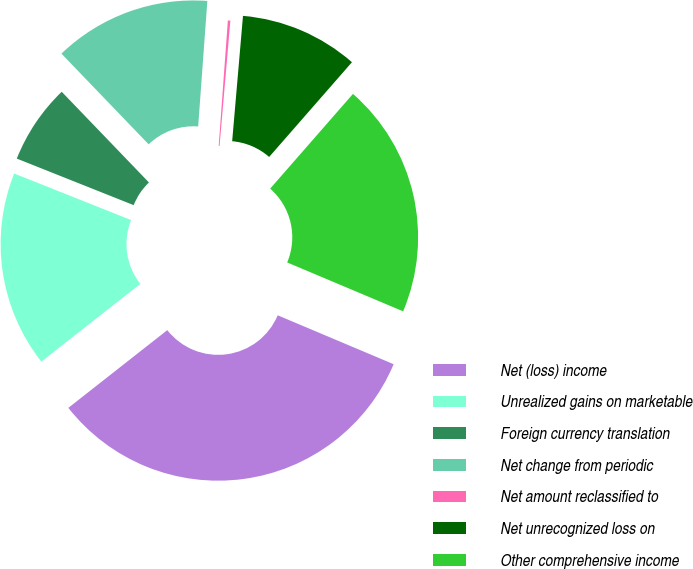Convert chart to OTSL. <chart><loc_0><loc_0><loc_500><loc_500><pie_chart><fcel>Net (loss) income<fcel>Unrealized gains on marketable<fcel>Foreign currency translation<fcel>Net change from periodic<fcel>Net amount reclassified to<fcel>Net unrecognized loss on<fcel>Other comprehensive income<nl><fcel>33.05%<fcel>16.63%<fcel>6.78%<fcel>13.35%<fcel>0.21%<fcel>10.06%<fcel>19.92%<nl></chart> 